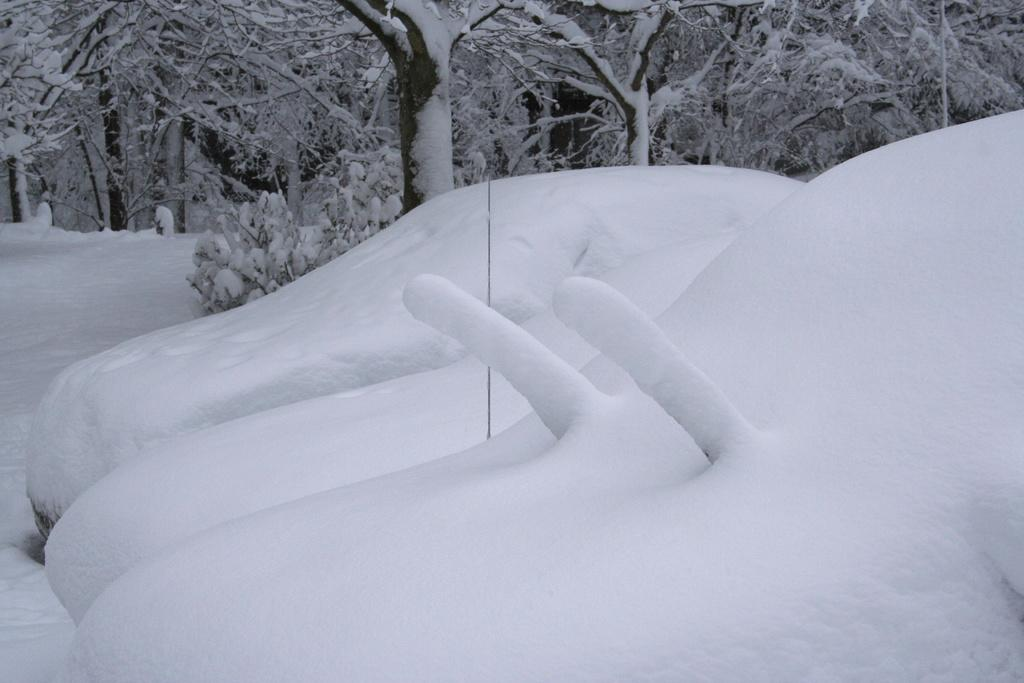What type of weather condition is depicted in the image? The image shows snow on the plants, trees, and cars, indicating a snowy weather condition. Can you describe the snow coverage on the plants? There is snow on the plants in the image. What else has snow accumulated on in the image? There is snow on the trees and cars in the image. Where is the pig standing in the image? There is no pig present in the image. Can you describe the flame coming from the tree in the image? There is no flame present in the image; it is a snowy scene with no fire or flames. 